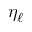<formula> <loc_0><loc_0><loc_500><loc_500>\eta _ { \ell }</formula> 